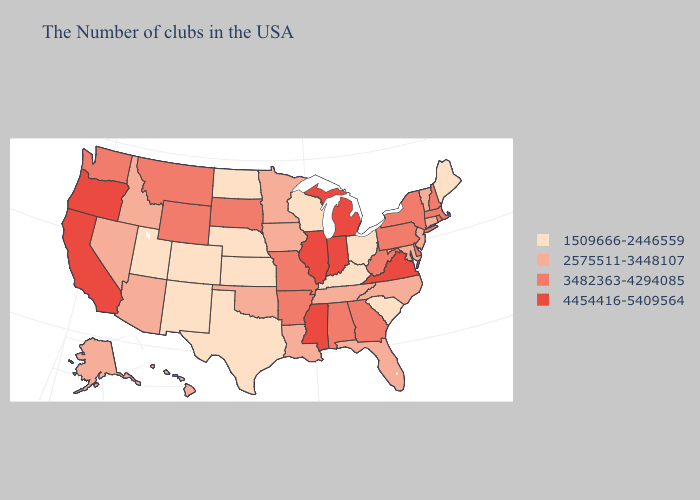What is the lowest value in states that border West Virginia?
Short answer required. 1509666-2446559. Does New York have the lowest value in the Northeast?
Quick response, please. No. What is the highest value in the Northeast ?
Give a very brief answer. 3482363-4294085. Is the legend a continuous bar?
Answer briefly. No. Name the states that have a value in the range 2575511-3448107?
Quick response, please. Vermont, Connecticut, New Jersey, Maryland, North Carolina, Florida, Tennessee, Louisiana, Minnesota, Iowa, Oklahoma, Arizona, Idaho, Nevada, Alaska, Hawaii. What is the value of Texas?
Concise answer only. 1509666-2446559. Among the states that border West Virginia , does Ohio have the lowest value?
Short answer required. Yes. Among the states that border Missouri , which have the highest value?
Be succinct. Illinois. Which states have the lowest value in the USA?
Answer briefly. Maine, South Carolina, Ohio, Kentucky, Wisconsin, Kansas, Nebraska, Texas, North Dakota, Colorado, New Mexico, Utah. What is the value of New York?
Give a very brief answer. 3482363-4294085. What is the value of Ohio?
Give a very brief answer. 1509666-2446559. Among the states that border California , which have the lowest value?
Give a very brief answer. Arizona, Nevada. What is the value of Oregon?
Give a very brief answer. 4454416-5409564. What is the value of Wisconsin?
Be succinct. 1509666-2446559. What is the value of South Carolina?
Concise answer only. 1509666-2446559. 